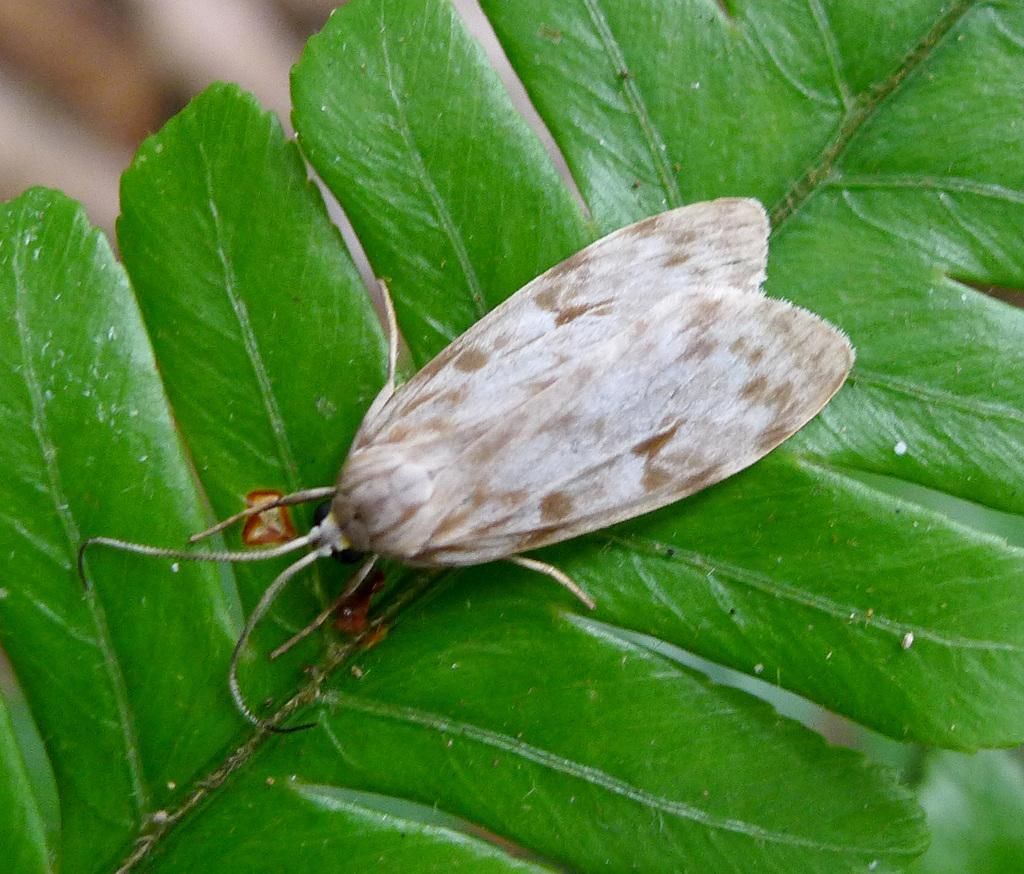What type of creature can be seen in the image? There is an insect present in the image. Where is the insect located in the image? The insect is on the leaves. What book is the insect reading in the image? There is no book or reading activity present in the image; it features an insect on the leaves. What type of wind can be seen in the image? There is no wind or zephyr present in the image; it features an insect on the leaves. 